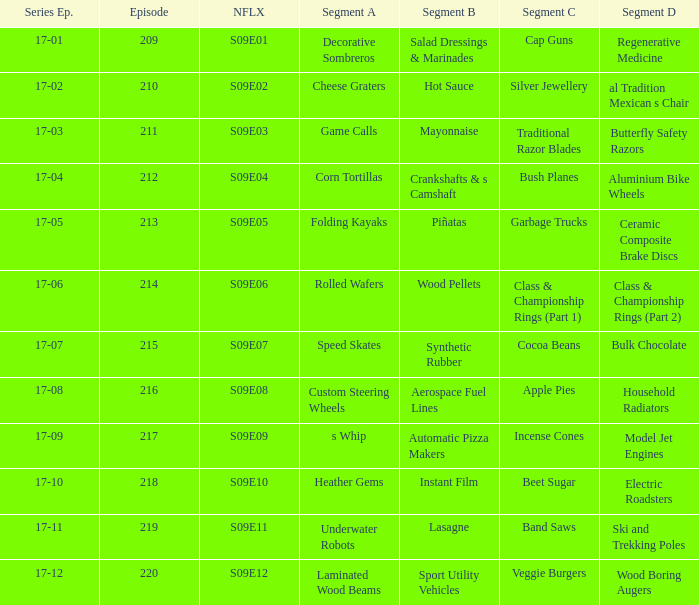How many segments involve wood boring augers Laminated Wood Beams. 